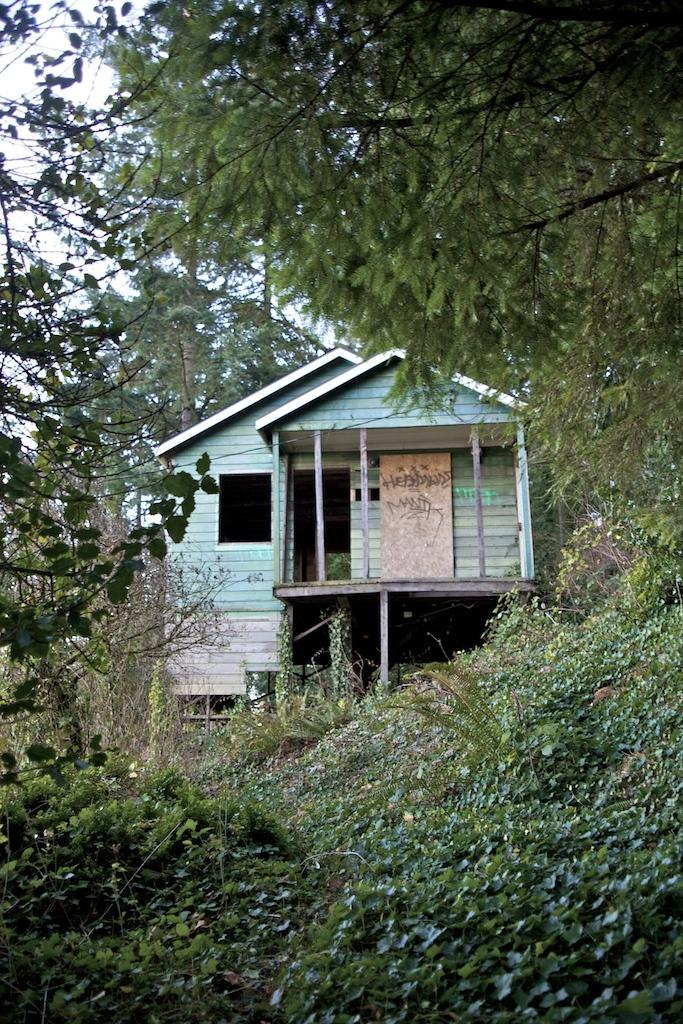What type of vegetation can be seen in the image? There are plants and trees in the image. What structure is located in the middle of the image? There is a shelter house in the middle of the image. What type of pollution can be seen in the image? There is no pollution visible in the image; it features plants, trees, and a shelter house. How many wheels are present on the shelter house in the image? There are no wheels present on the shelter house in the image. 